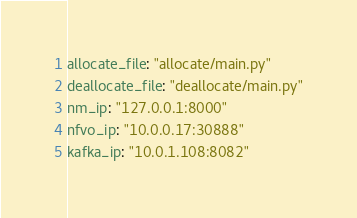Convert code to text. <code><loc_0><loc_0><loc_500><loc_500><_YAML_>allocate_file: "allocate/main.py"
deallocate_file: "deallocate/main.py"
nm_ip: "127.0.0.1:8000"
nfvo_ip: "10.0.0.17:30888"
kafka_ip: "10.0.1.108:8082"</code> 